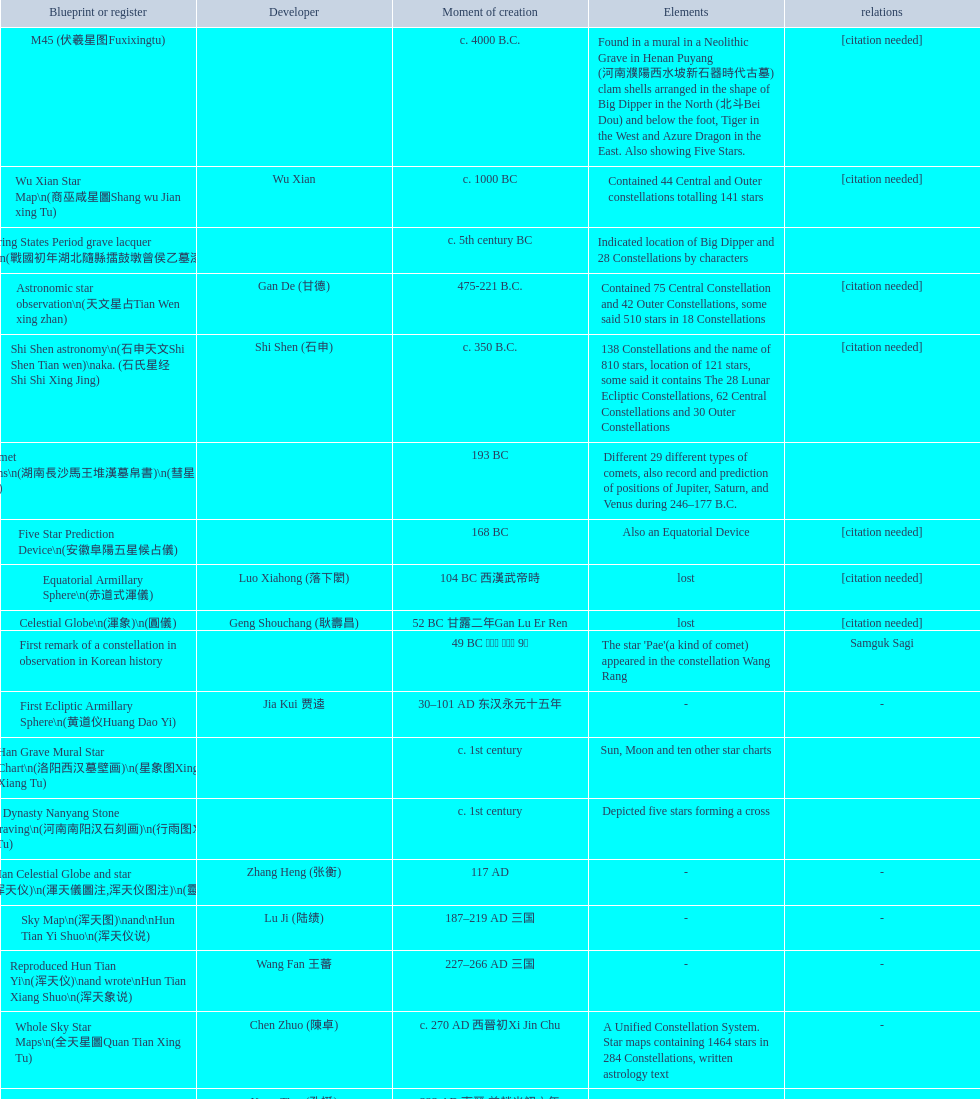Which star map was created earlier, celestial globe or the han grave mural star chart? Celestial Globe. 